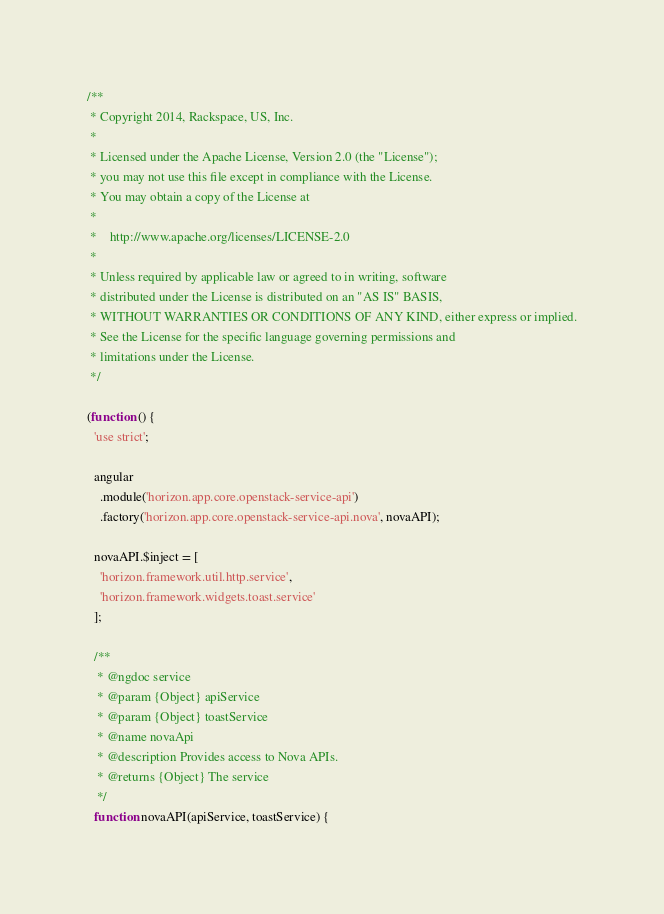<code> <loc_0><loc_0><loc_500><loc_500><_JavaScript_>/**
 * Copyright 2014, Rackspace, US, Inc.
 *
 * Licensed under the Apache License, Version 2.0 (the "License");
 * you may not use this file except in compliance with the License.
 * You may obtain a copy of the License at
 *
 *    http://www.apache.org/licenses/LICENSE-2.0
 *
 * Unless required by applicable law or agreed to in writing, software
 * distributed under the License is distributed on an "AS IS" BASIS,
 * WITHOUT WARRANTIES OR CONDITIONS OF ANY KIND, either express or implied.
 * See the License for the specific language governing permissions and
 * limitations under the License.
 */

(function () {
  'use strict';

  angular
    .module('horizon.app.core.openstack-service-api')
    .factory('horizon.app.core.openstack-service-api.nova', novaAPI);

  novaAPI.$inject = [
    'horizon.framework.util.http.service',
    'horizon.framework.widgets.toast.service'
  ];

  /**
   * @ngdoc service
   * @param {Object} apiService
   * @param {Object} toastService
   * @name novaApi
   * @description Provides access to Nova APIs.
   * @returns {Object} The service
   */
  function novaAPI(apiService, toastService) {
</code> 